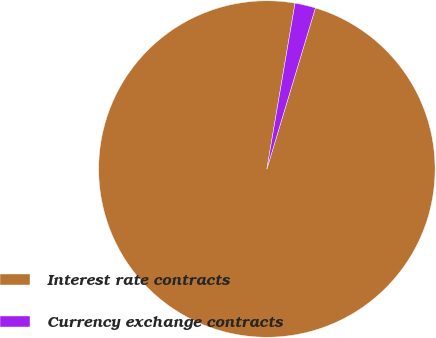Convert chart. <chart><loc_0><loc_0><loc_500><loc_500><pie_chart><fcel>Interest rate contracts<fcel>Currency exchange contracts<nl><fcel>98.02%<fcel>1.98%<nl></chart> 